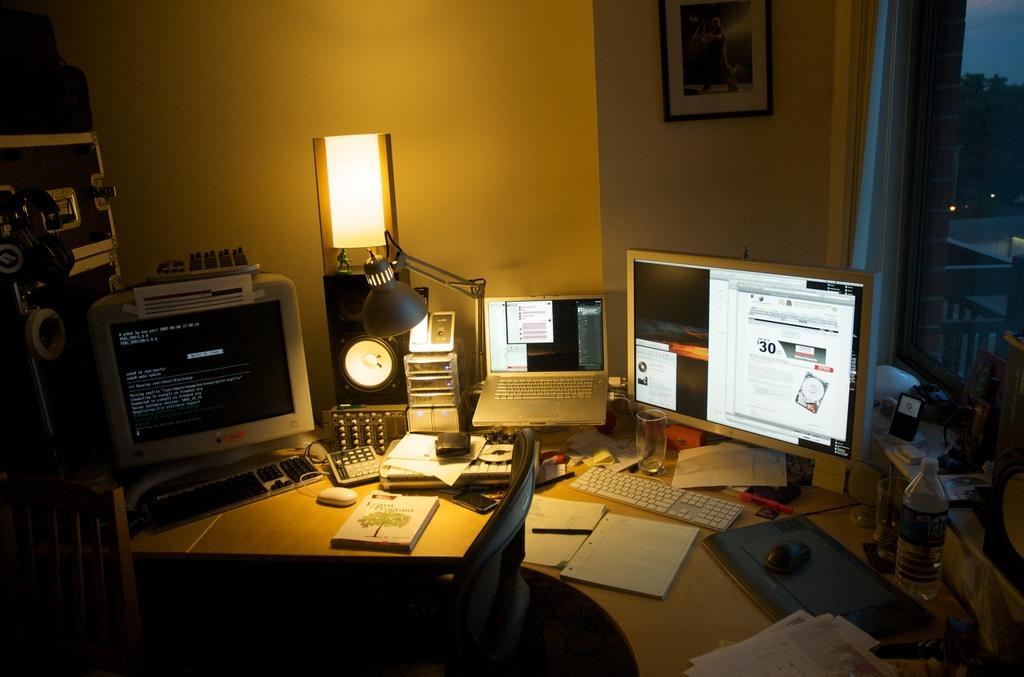How would you summarize this image in a sentence or two? In this picture we can see a table, there are monitors, keyboards, mouses, a laptop, books, a speaker, a light, a bottle, papers, a glass and other things on this table, in the background there is a wall, we can see a photo frame and a glass on the right side, from the glass we can see a tree. 